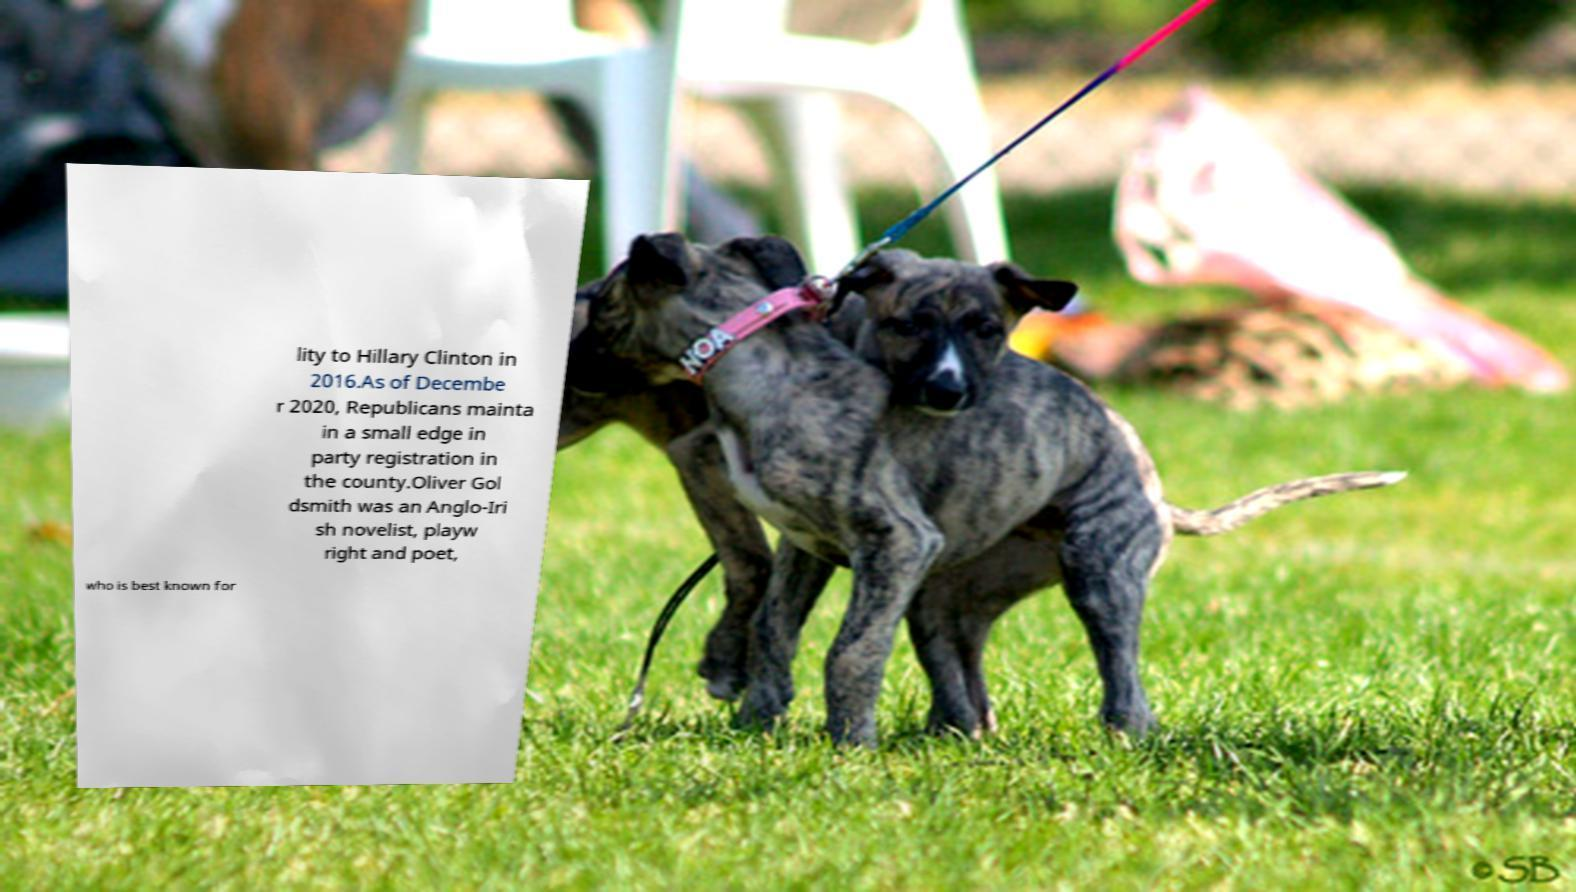Can you accurately transcribe the text from the provided image for me? lity to Hillary Clinton in 2016.As of Decembe r 2020, Republicans mainta in a small edge in party registration in the county.Oliver Gol dsmith was an Anglo-Iri sh novelist, playw right and poet, who is best known for 